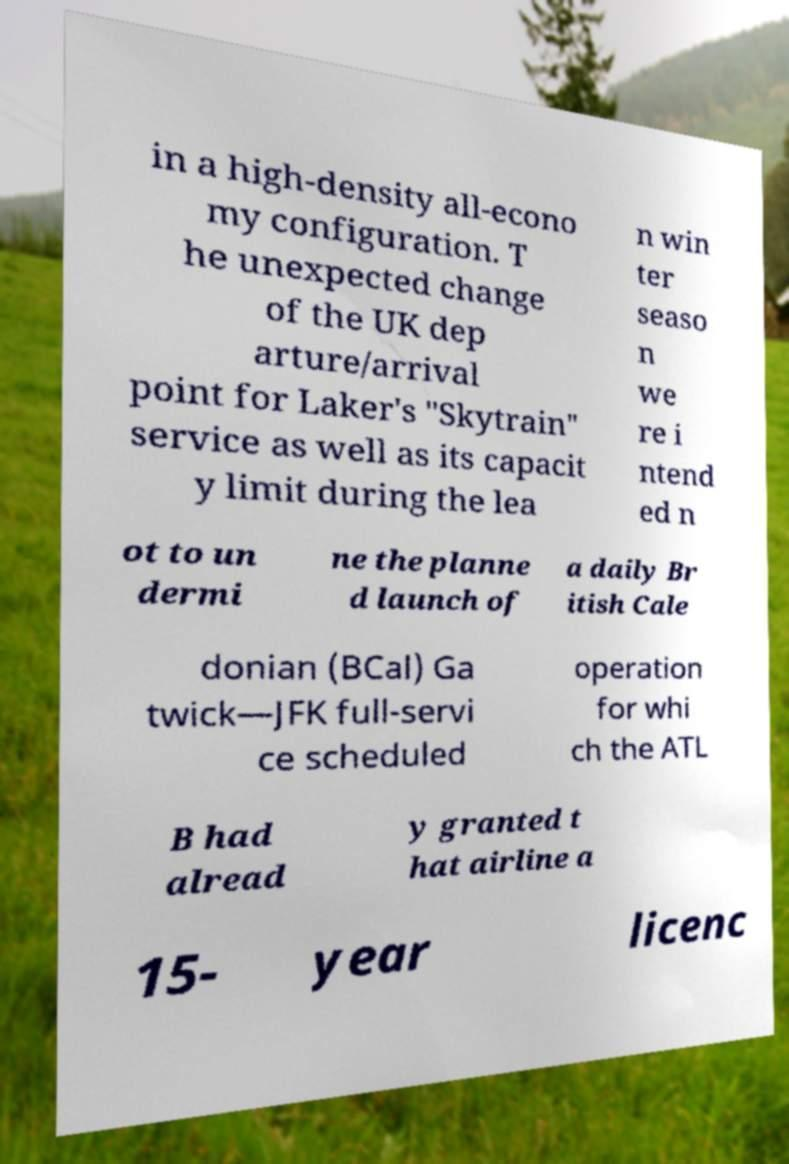Please read and relay the text visible in this image. What does it say? in a high-density all-econo my configuration. T he unexpected change of the UK dep arture/arrival point for Laker's "Skytrain" service as well as its capacit y limit during the lea n win ter seaso n we re i ntend ed n ot to un dermi ne the planne d launch of a daily Br itish Cale donian (BCal) Ga twick—JFK full-servi ce scheduled operation for whi ch the ATL B had alread y granted t hat airline a 15- year licenc 